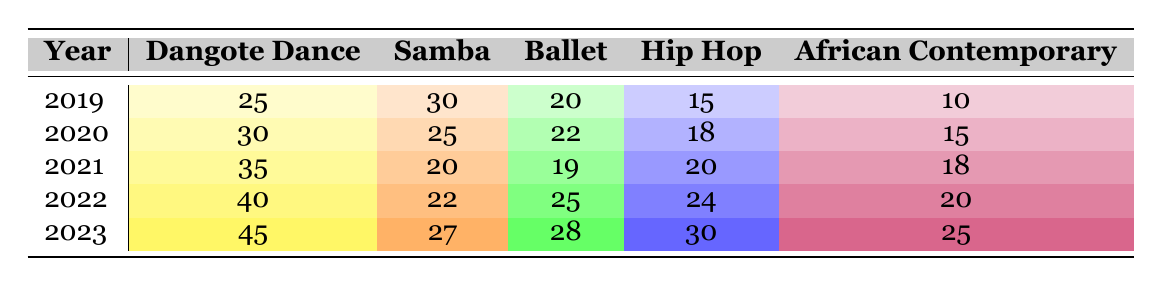What was the enrollment for African Contemporary in 2020? In the year 2020, I can refer directly to the table and locate the row for that year. It indicates that the enrollment for African Contemporary was 15 students.
Answer: 15 Which dance style had the highest enrollment in 2022? In 2022, I compare all the enrollment numbers listed for each dance style: Dangote Dance (40), Samba (22), Ballet (25), Hip Hop (24), and African Contemporary (20). The highest number is for Dangote Dance, which had 40 students.
Answer: Dangote Dance What is the total enrollment for Hip Hop across all years? I need to sum the enrollment numbers for Hip Hop for each year: 15 (2019) + 18 (2020) + 20 (2021) + 24 (2022) + 30 (2023). This totals to 107 students.
Answer: 107 Did the enrollment for Samba decrease from 2019 to 2021? I check the enrollment for Samba in each of those years from the table: 30 (2019), 25 (2020), 20 (2021). Since the numbers go from 30 to 20, it indicates a decrease.
Answer: Yes What was the average enrollment for Ballet from 2019 to 2023? To find the average, I first sum the enrollment for Ballet: 20 (2019) + 22 (2020) + 19 (2021) + 25 (2022) + 28 (2023) = 114. There are 5 years, so I divide 114 by 5 to get an average of 22.8.
Answer: 22.8 Which year saw the maximum enrollment for Dangote Dance? By checking the enrollment numbers for Dangote Dance across the years, I find: 25 (2019), 30 (2020), 35 (2021), 40 (2022), and 45 (2023). The maximum is in the year 2023 with 45 students.
Answer: 2023 What is the difference in enrollment for African Contemporary between 2019 and 2023? I look at the enrollment for African Contemporary: 10 (2019) and 25 (2023). I subtract the earlier year's number from the later year's: 25 - 10 results in a difference of 15 students.
Answer: 15 Was the enrollment for Hip Hop higher in 2023 than in 2021? Looking at the enrollment for both years, Hip Hop had 20 students in 2021 and 30 students in 2023. Since 30 is greater than 20, the enrollment increased.
Answer: Yes In which year did Ballet have the least enrollment? I check the Ballet enrollment figures: 20 (2019), 22 (2020), 19 (2021), 25 (2022), 28 (2023). The least number is 19 in the year 2021.
Answer: 2021 